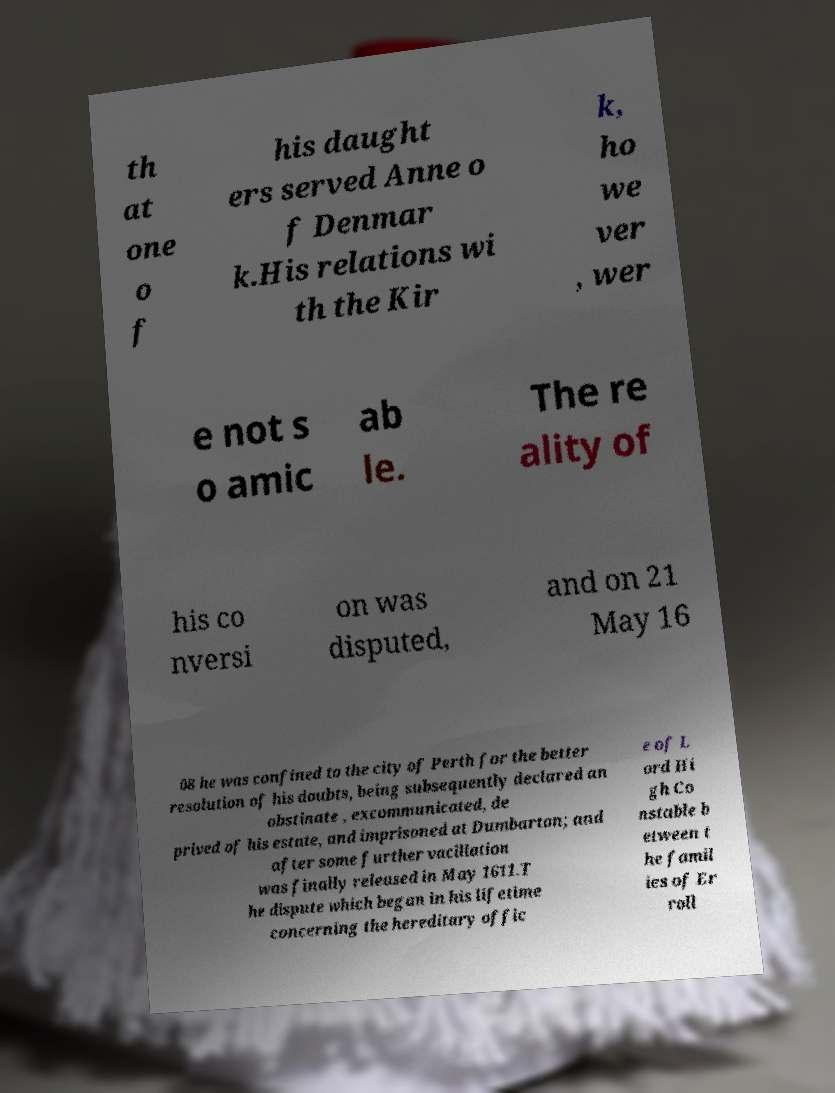Please identify and transcribe the text found in this image. th at one o f his daught ers served Anne o f Denmar k.His relations wi th the Kir k, ho we ver , wer e not s o amic ab le. The re ality of his co nversi on was disputed, and on 21 May 16 08 he was confined to the city of Perth for the better resolution of his doubts, being subsequently declared an obstinate , excommunicated, de prived of his estate, and imprisoned at Dumbarton; and after some further vacillation was finally released in May 1611.T he dispute which began in his lifetime concerning the hereditary offic e of L ord Hi gh Co nstable b etween t he famil ies of Er roll 